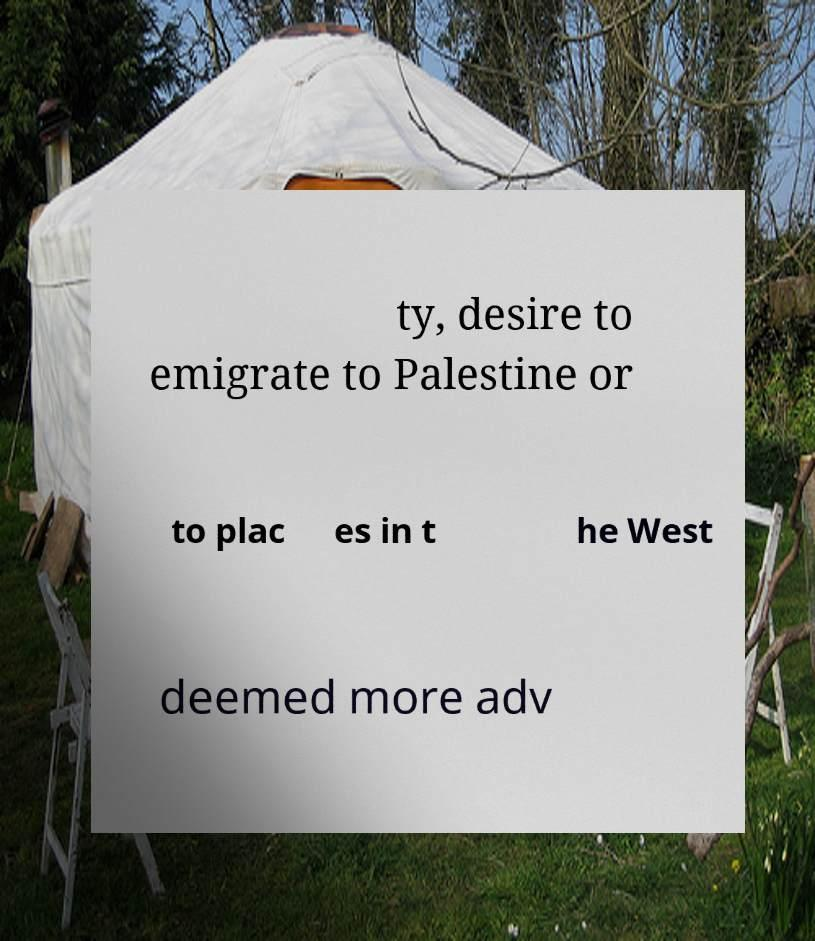Can you accurately transcribe the text from the provided image for me? ty, desire to emigrate to Palestine or to plac es in t he West deemed more adv 